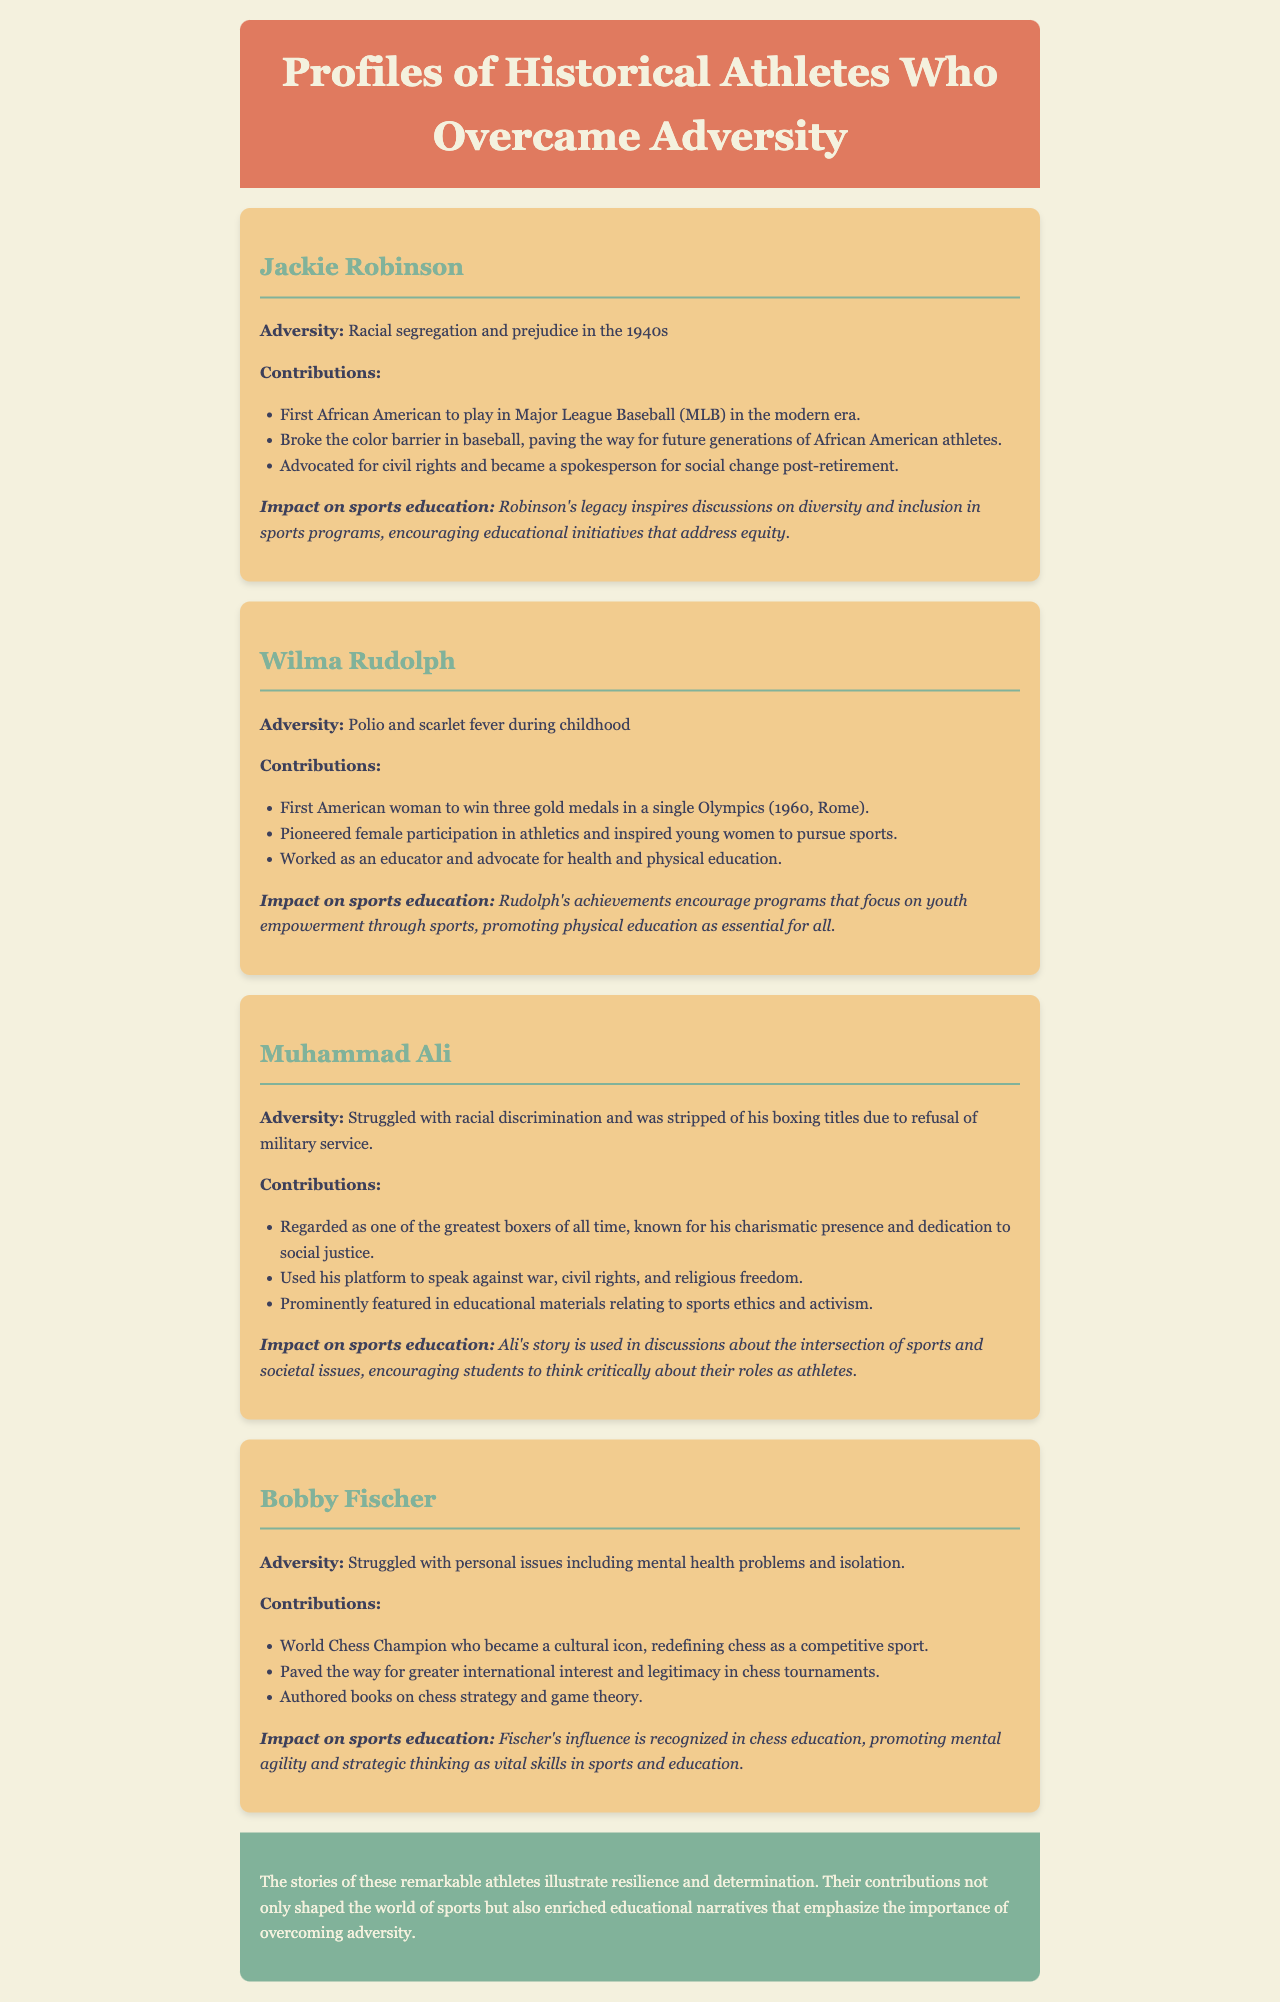What adversity did Jackie Robinson face? Jackie Robinson faced racial segregation and prejudice in the 1940s.
Answer: Racial segregation and prejudice How many gold medals did Wilma Rudolph win in the 1960 Olympics? Wilma Rudolph won three gold medals in the 1960 Olympics.
Answer: Three What effect did Muhammad Ali have on discussions about sports ethics? Muhammad Ali's story is used in discussions about the intersection of sports and societal issues.
Answer: Intersection of sports and societal issues What sport did Bobby Fischer redefine? Bobby Fischer redefined chess as a competitive sport.
Answer: Chess What advocacy work did Wilma Rudolph engage in? Wilma Rudolph worked as an educator and advocate for health and physical education.
Answer: Advocate for health and physical education Who broke the color barrier in baseball? Jackie Robinson broke the color barrier in baseball.
Answer: Jackie Robinson What kind of issues did Muhammad Ali speak against? Muhammad Ali spoke against war, civil rights, and religious freedom.
Answer: War, civil rights, and religious freedom What was the impact of Jackie Robinson's legacy? Robinson's legacy inspires discussions on diversity and inclusion in sports programs.
Answer: Diversity and inclusion in sports programs What is the overarching theme of the athletes' stories? The overarching theme is resilience and determination.
Answer: Resilience and determination 